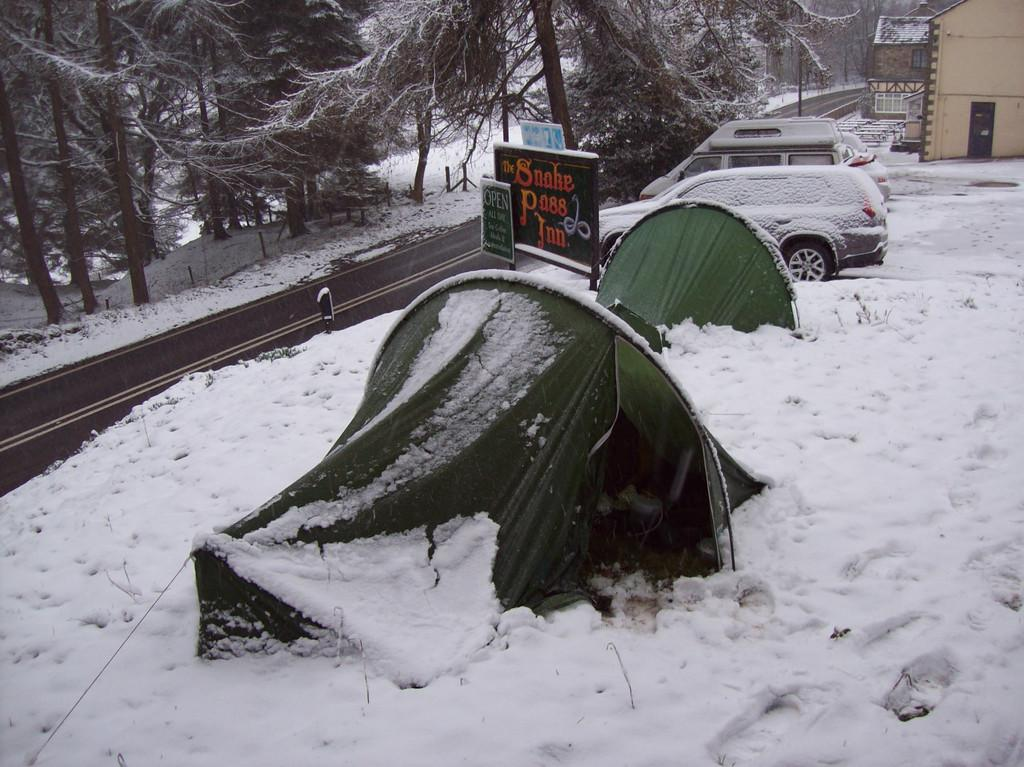<image>
Share a concise interpretation of the image provided. Green tent with a sign which says Smoke Pass Inn. 